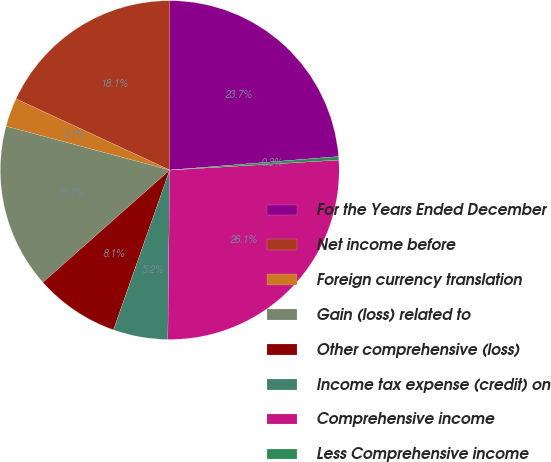Convert chart. <chart><loc_0><loc_0><loc_500><loc_500><pie_chart><fcel>For the Years Ended December<fcel>Net income before<fcel>Foreign currency translation<fcel>Gain (loss) related to<fcel>Other comprehensive (loss)<fcel>Income tax expense (credit) on<fcel>Comprehensive income<fcel>Less Comprehensive income<nl><fcel>23.72%<fcel>18.1%<fcel>2.74%<fcel>15.7%<fcel>8.08%<fcel>5.21%<fcel>26.12%<fcel>0.33%<nl></chart> 